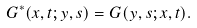Convert formula to latex. <formula><loc_0><loc_0><loc_500><loc_500>G ^ { * } ( x , t ; y , s ) = G ( y , s ; x , t ) .</formula> 